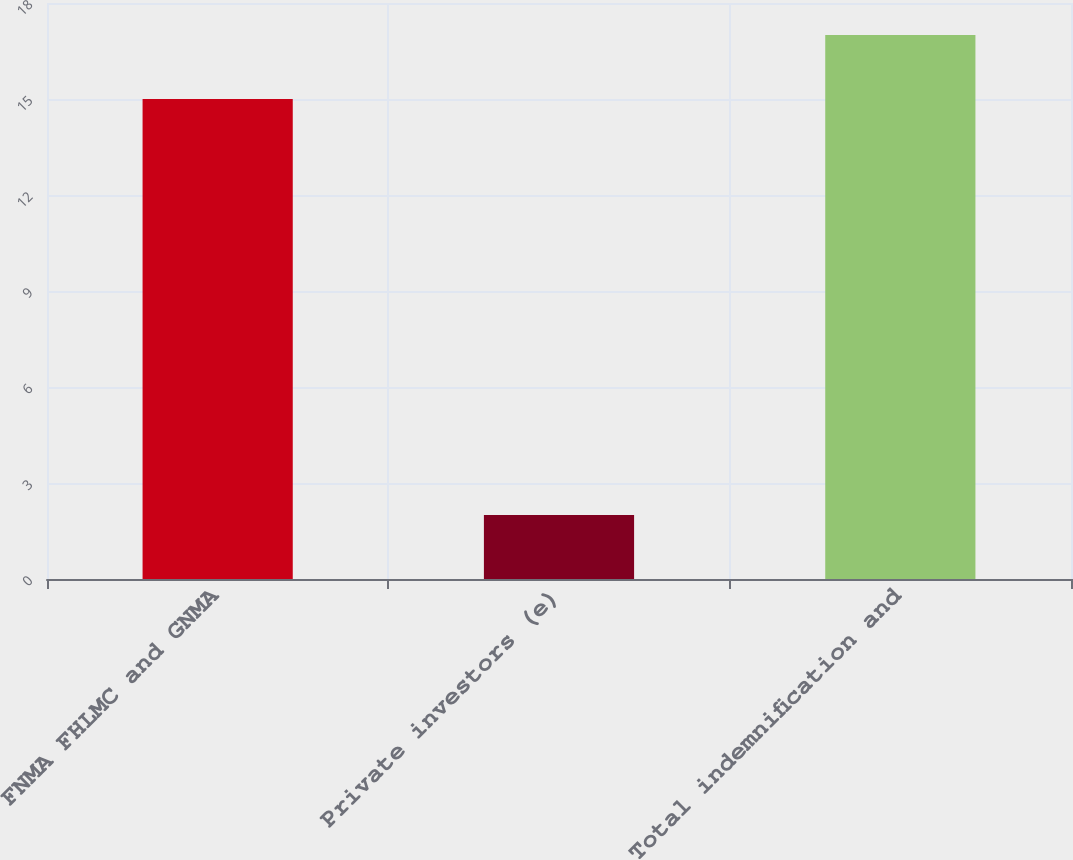Convert chart. <chart><loc_0><loc_0><loc_500><loc_500><bar_chart><fcel>FNMA FHLMC and GNMA<fcel>Private investors (e)<fcel>Total indemnification and<nl><fcel>15<fcel>2<fcel>17<nl></chart> 